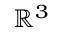<formula> <loc_0><loc_0><loc_500><loc_500>{ \mathbb { R } } ^ { 3 }</formula> 